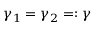Convert formula to latex. <formula><loc_0><loc_0><loc_500><loc_500>\gamma _ { 1 } = \gamma _ { 2 } = \colon \gamma</formula> 